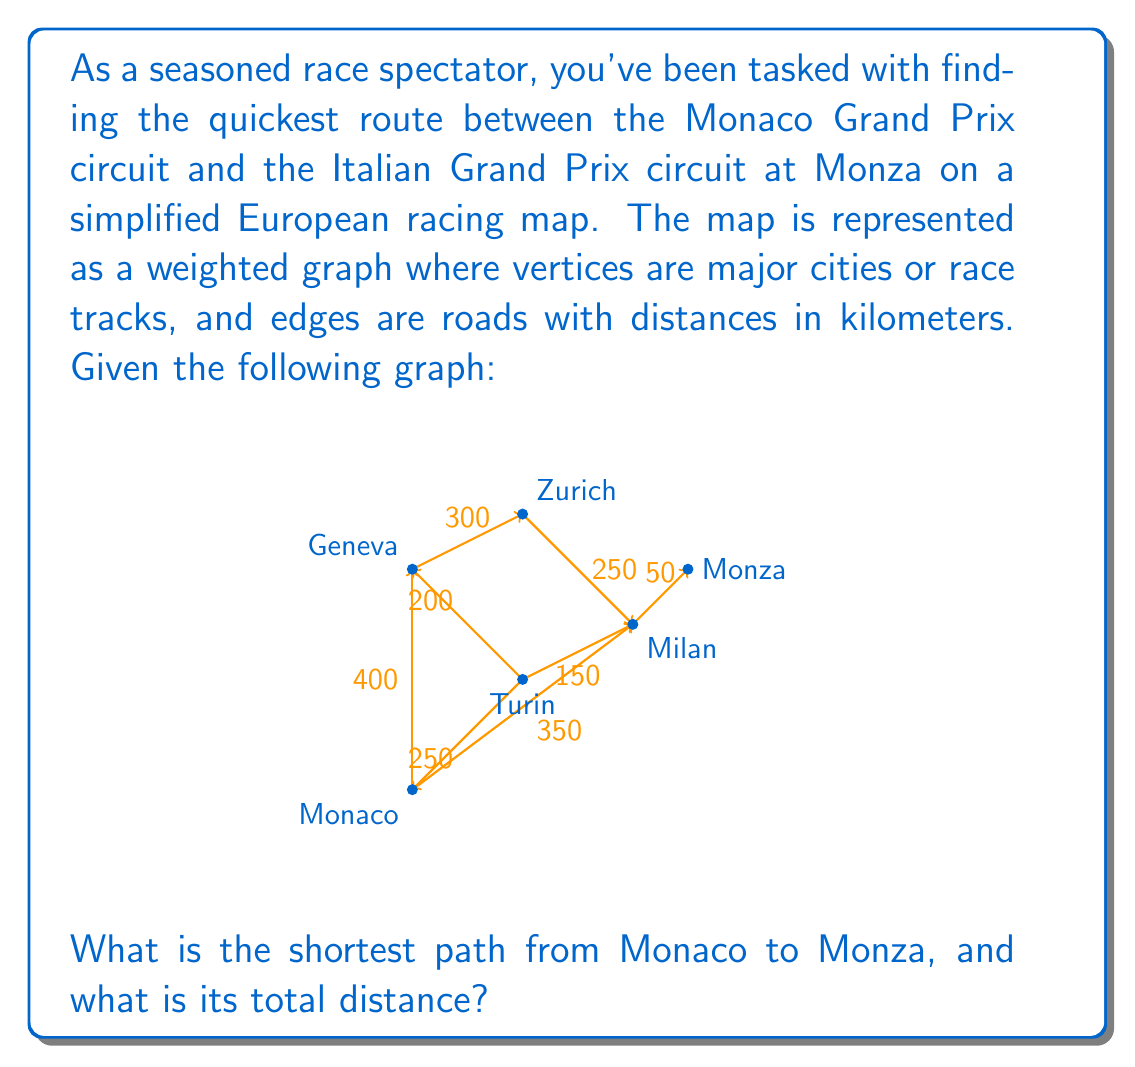Provide a solution to this math problem. To solve this problem, we can use Dijkstra's algorithm, which is an efficient method for finding the shortest path between nodes in a graph. Let's follow the steps:

1) Initialize:
   - Set distance to Monaco as 0 and all other nodes as infinity.
   - Set all nodes as unvisited.
   - Set Monaco as the current node.

2) For the current node, consider all unvisited neighbors and calculate their tentative distances.
   - Monaco to Geneva: 400 km
   - Monaco to Milan: 350 km
   - Monaco to Turin: 250 km

3) Mark Monaco as visited. The current shortest paths are:
   Monaco → Geneva: 400 km
   Monaco → Milan: 350 km
   Monaco → Turin: 250 km

4) Select Turin as the new current node (shortest tentative distance).

5) Update distances:
   - Turin to Geneva: 250 + 200 = 450 km (not shorter)
   - Turin to Milan: 250 + 150 = 400 km (shorter than direct Monaco → Milan)

6) Mark Turin as visited. Current shortest paths:
   Monaco → Turin → Milan: 400 km
   Monaco → Geneva: 400 km

7) Select Milan as the new current node.

8) Update distances:
   - Milan to Zurich: 400 + 250 = 650 km
   - Milan to Monza: 400 + 50 = 450 km

9) Mark Milan as visited. The shortest path to Monza is now known.

The algorithm would continue, but we've already found the shortest path to Monza.

The shortest path is: Monaco → Turin → Milan → Monza
Total distance: 250 + 150 + 50 = 450 km
Answer: The shortest path from Monaco to Monza is Monaco → Turin → Milan → Monza, with a total distance of 450 km. 